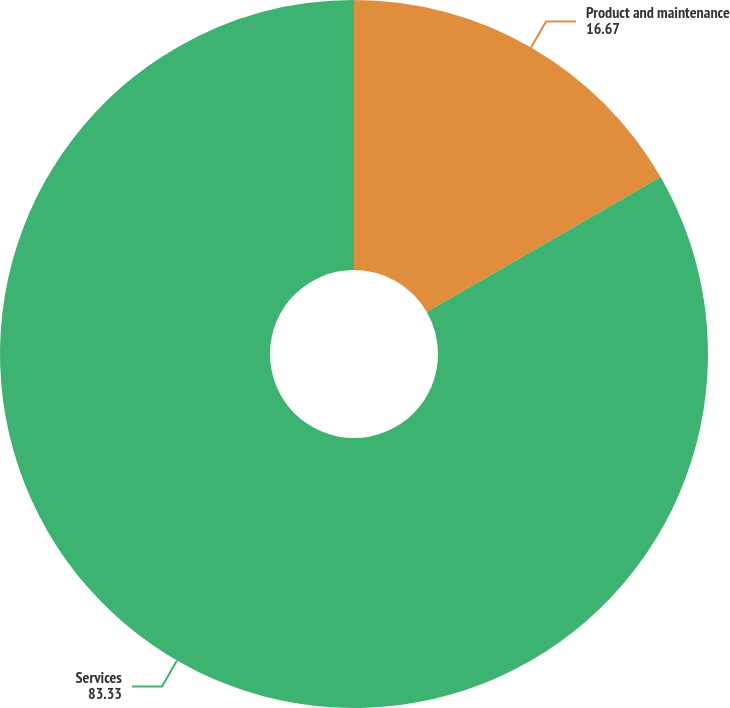Convert chart. <chart><loc_0><loc_0><loc_500><loc_500><pie_chart><fcel>Product and maintenance<fcel>Services<nl><fcel>16.67%<fcel>83.33%<nl></chart> 